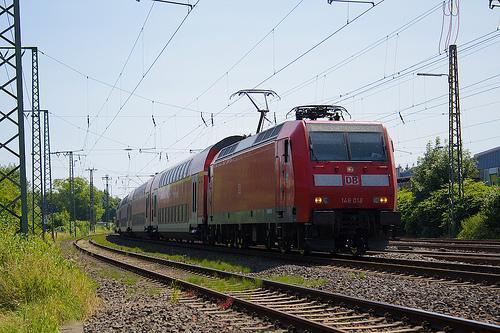How many trains are there?
Give a very brief answer. 1. 